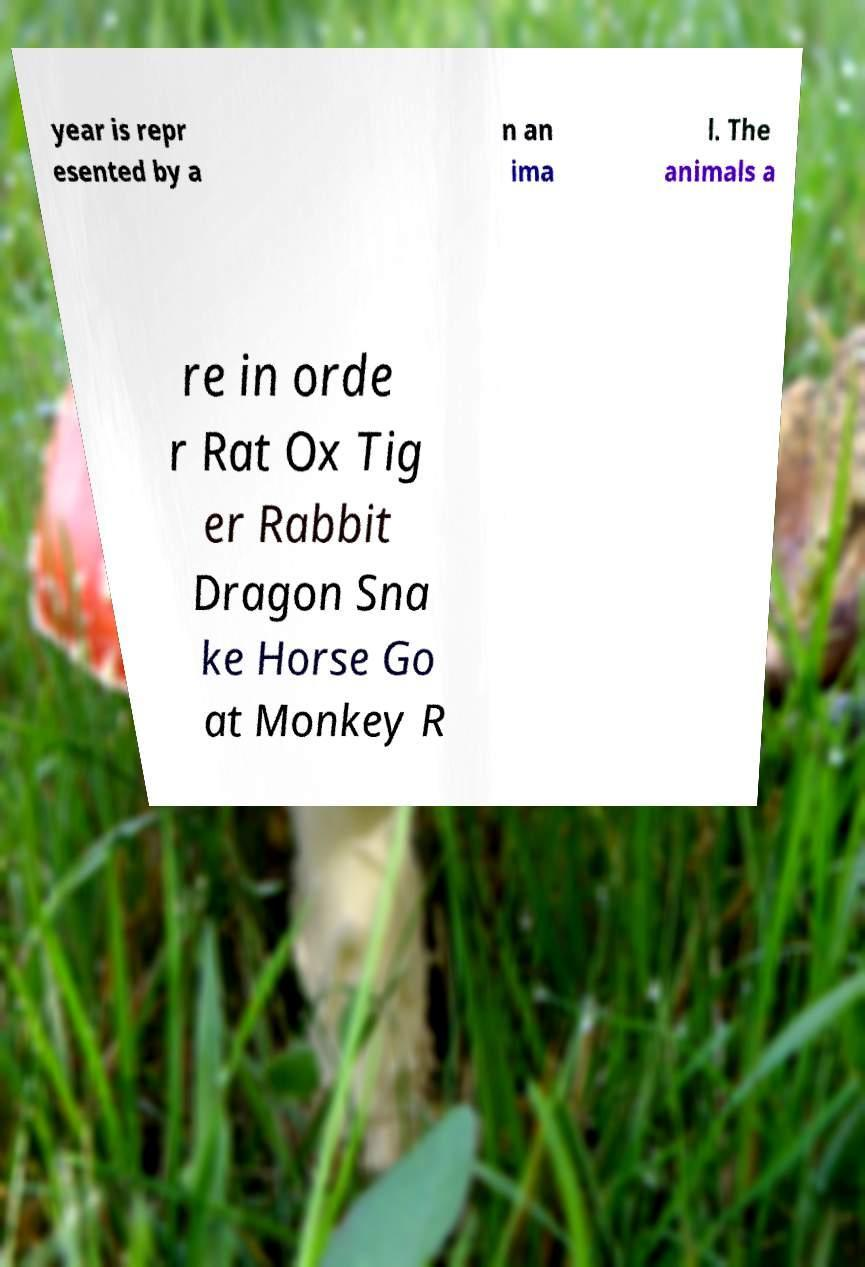Please read and relay the text visible in this image. What does it say? year is repr esented by a n an ima l. The animals a re in orde r Rat Ox Tig er Rabbit Dragon Sna ke Horse Go at Monkey R 